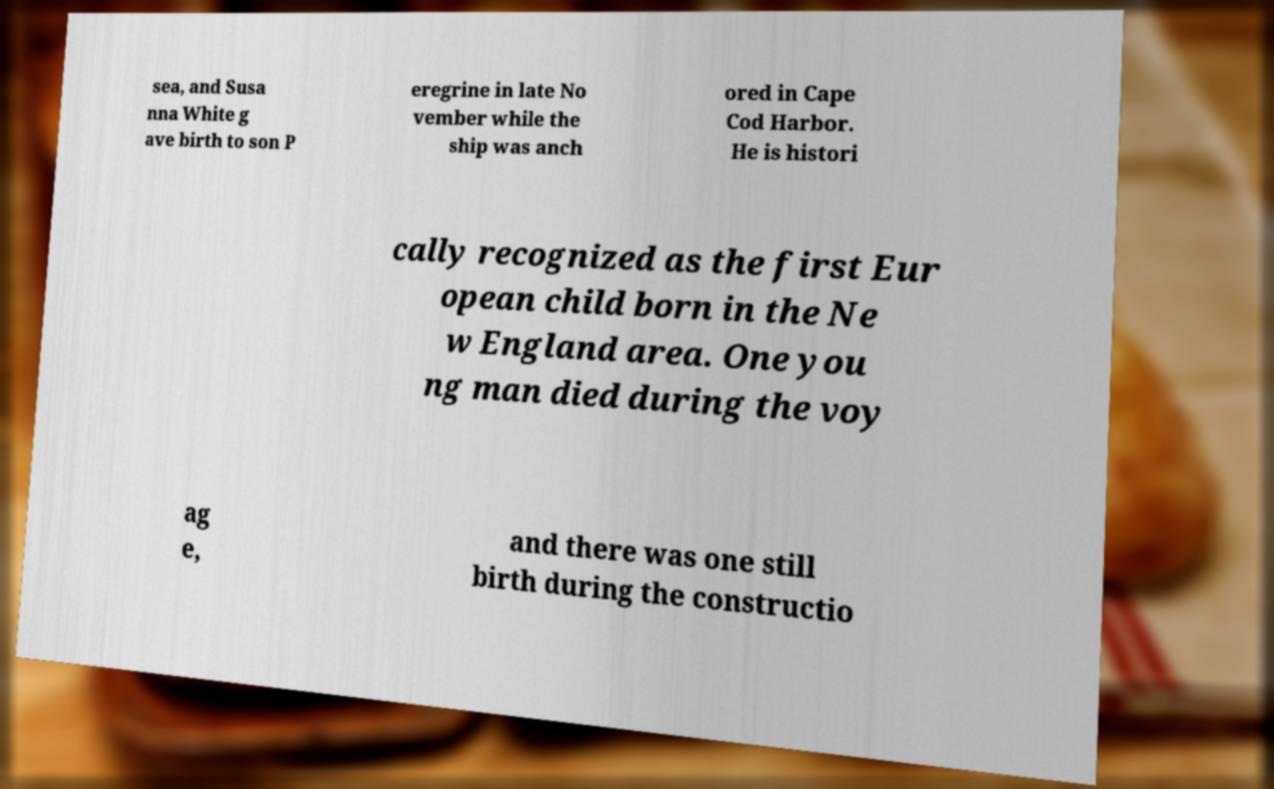What messages or text are displayed in this image? I need them in a readable, typed format. sea, and Susa nna White g ave birth to son P eregrine in late No vember while the ship was anch ored in Cape Cod Harbor. He is histori cally recognized as the first Eur opean child born in the Ne w England area. One you ng man died during the voy ag e, and there was one still birth during the constructio 